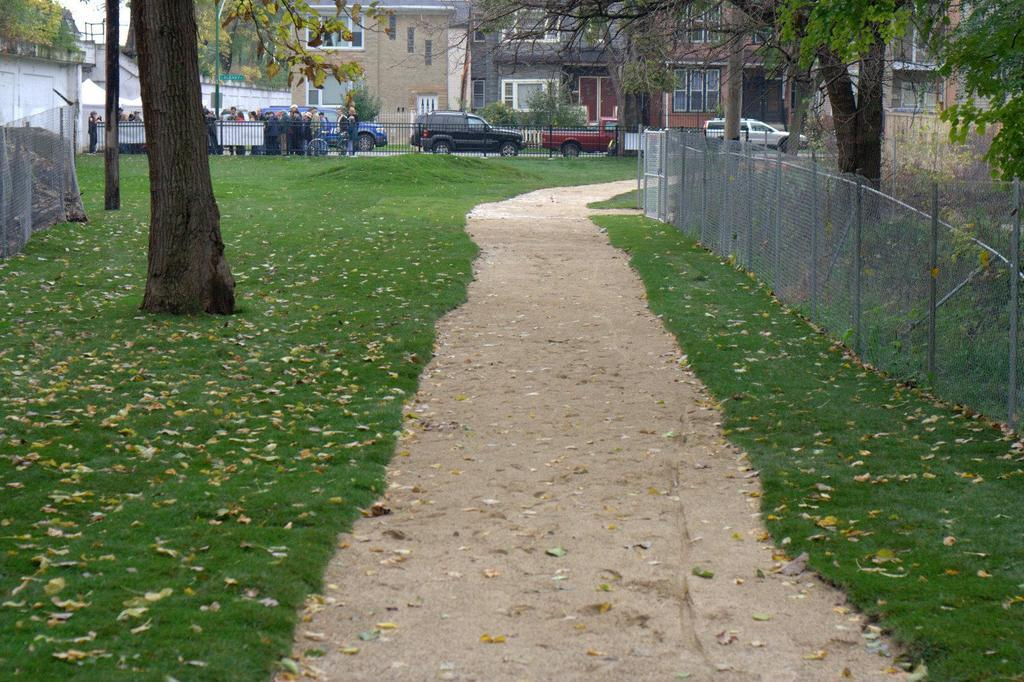What type of vegetation covers the land in the image? The land is covered with grass. What can be seen in the distance beyond the grassy land? There are buildings with windows in the distance. What is happening near the fence in the image? There are people and vehicles near a fence. What type of barrier is visible in the image? There is a fence visible in the image. What other natural elements are present in the image? Trees are present in the image. Can you see any beds in the image? There are no beds present in the image. Is there a gun visible in the image? There is no gun visible in the image. 